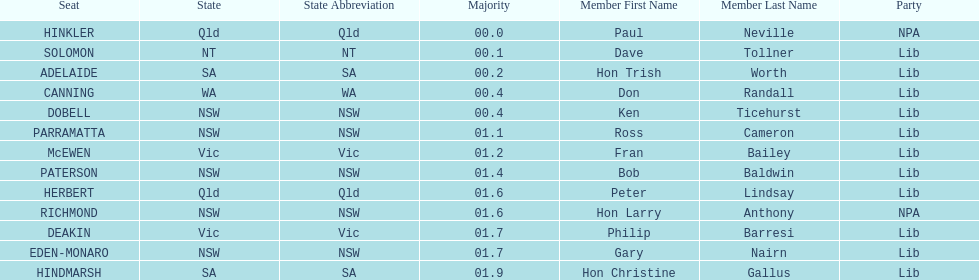What is the difference in majority between hindmarsh and hinkler? 01.9. 